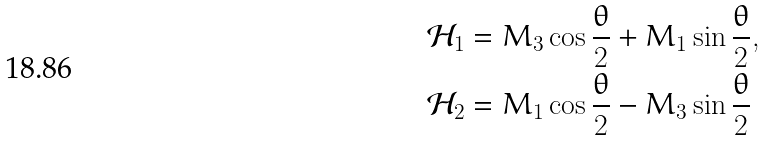<formula> <loc_0><loc_0><loc_500><loc_500>\mathcal { H } _ { 1 } & = M _ { 3 } \cos \frac { \theta } { 2 } + M _ { 1 } \sin \frac { \theta } { 2 } , \\ \mathcal { H } _ { 2 } & = M _ { 1 } \cos \frac { \theta } { 2 } - M _ { 3 } \sin \frac { \theta } { 2 }</formula> 